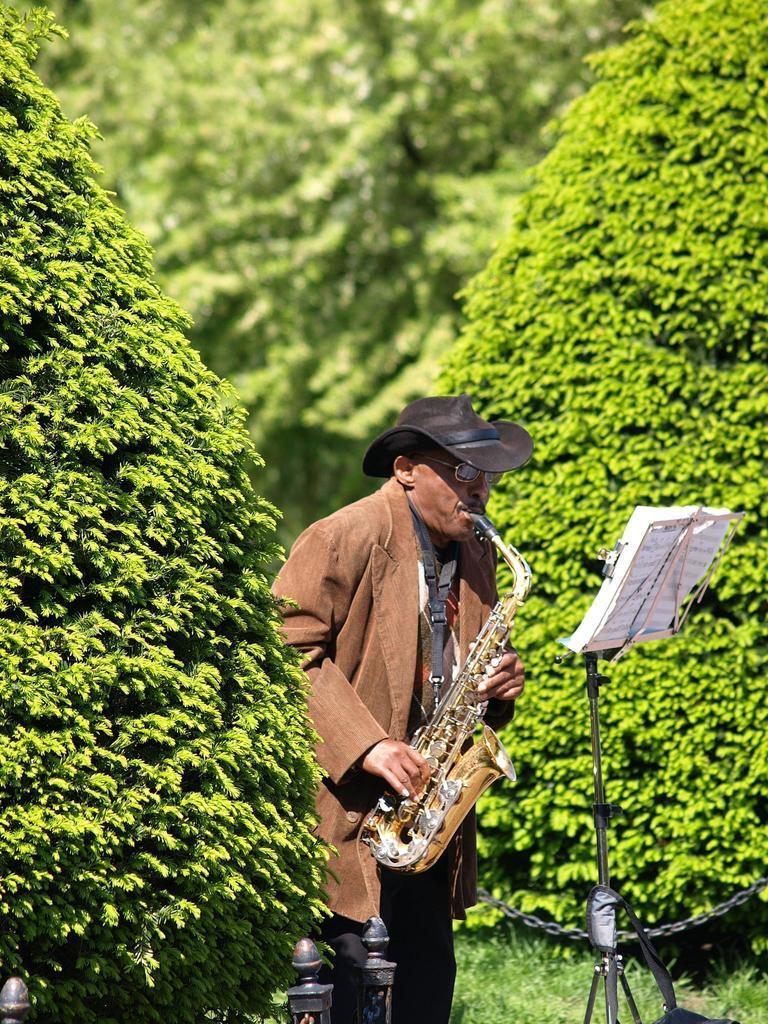Describe this image in one or two sentences. This picture is clicked outside. In the foreground we can see a man wearing jacket, hat, standing and seems to be playing a saxophone. On the right we can see the papers are attached to the metal stand and we can see some metal objects. In the background we can see the trees and the green grass. 